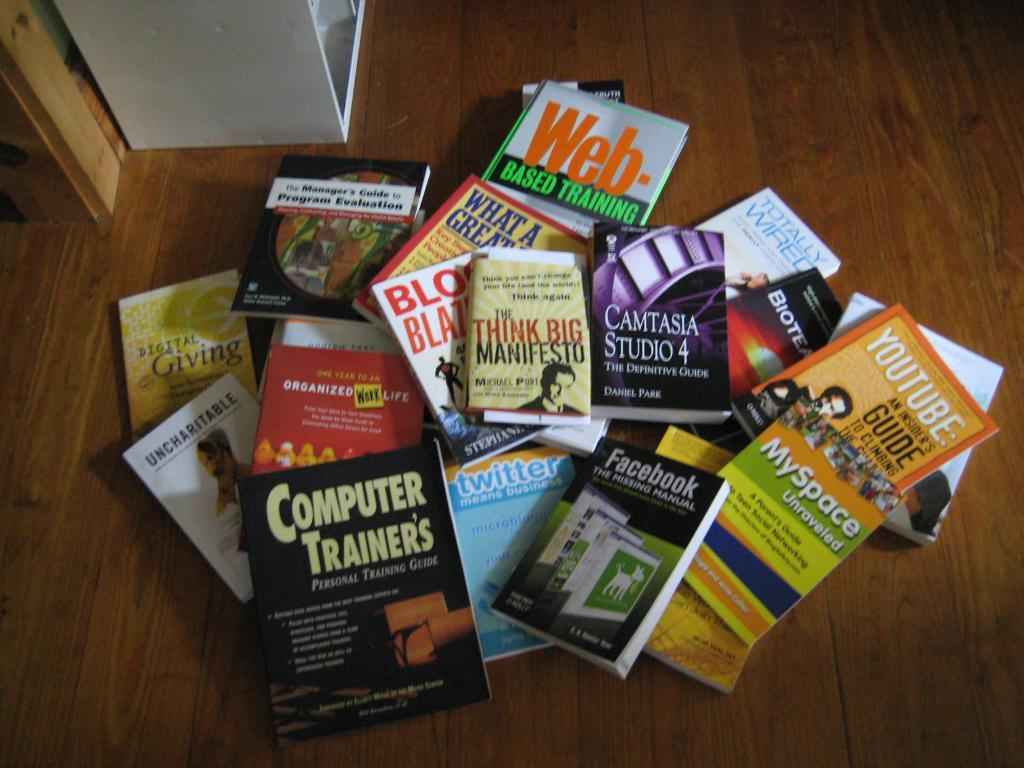<image>
Present a compact description of the photo's key features. A book about Facebook is in a pile of other books. 